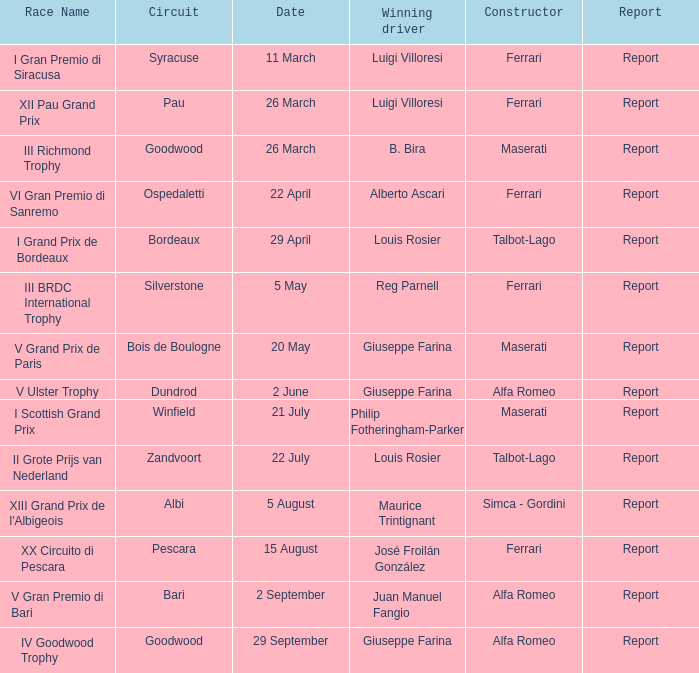Parse the full table. {'header': ['Race Name', 'Circuit', 'Date', 'Winning driver', 'Constructor', 'Report'], 'rows': [['I Gran Premio di Siracusa', 'Syracuse', '11 March', 'Luigi Villoresi', 'Ferrari', 'Report'], ['XII Pau Grand Prix', 'Pau', '26 March', 'Luigi Villoresi', 'Ferrari', 'Report'], ['III Richmond Trophy', 'Goodwood', '26 March', 'B. Bira', 'Maserati', 'Report'], ['VI Gran Premio di Sanremo', 'Ospedaletti', '22 April', 'Alberto Ascari', 'Ferrari', 'Report'], ['I Grand Prix de Bordeaux', 'Bordeaux', '29 April', 'Louis Rosier', 'Talbot-Lago', 'Report'], ['III BRDC International Trophy', 'Silverstone', '5 May', 'Reg Parnell', 'Ferrari', 'Report'], ['V Grand Prix de Paris', 'Bois de Boulogne', '20 May', 'Giuseppe Farina', 'Maserati', 'Report'], ['V Ulster Trophy', 'Dundrod', '2 June', 'Giuseppe Farina', 'Alfa Romeo', 'Report'], ['I Scottish Grand Prix', 'Winfield', '21 July', 'Philip Fotheringham-Parker', 'Maserati', 'Report'], ['II Grote Prijs van Nederland', 'Zandvoort', '22 July', 'Louis Rosier', 'Talbot-Lago', 'Report'], ["XIII Grand Prix de l'Albigeois", 'Albi', '5 August', 'Maurice Trintignant', 'Simca - Gordini', 'Report'], ['XX Circuito di Pescara', 'Pescara', '15 August', 'José Froilán González', 'Ferrari', 'Report'], ['V Gran Premio di Bari', 'Bari', '2 September', 'Juan Manuel Fangio', 'Alfa Romeo', 'Report'], ['IV Goodwood Trophy', 'Goodwood', '29 September', 'Giuseppe Farina', 'Alfa Romeo', 'Report']]} What is the report called for the v grand prix de paris event? Report. 